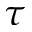<formula> <loc_0><loc_0><loc_500><loc_500>\tau</formula> 